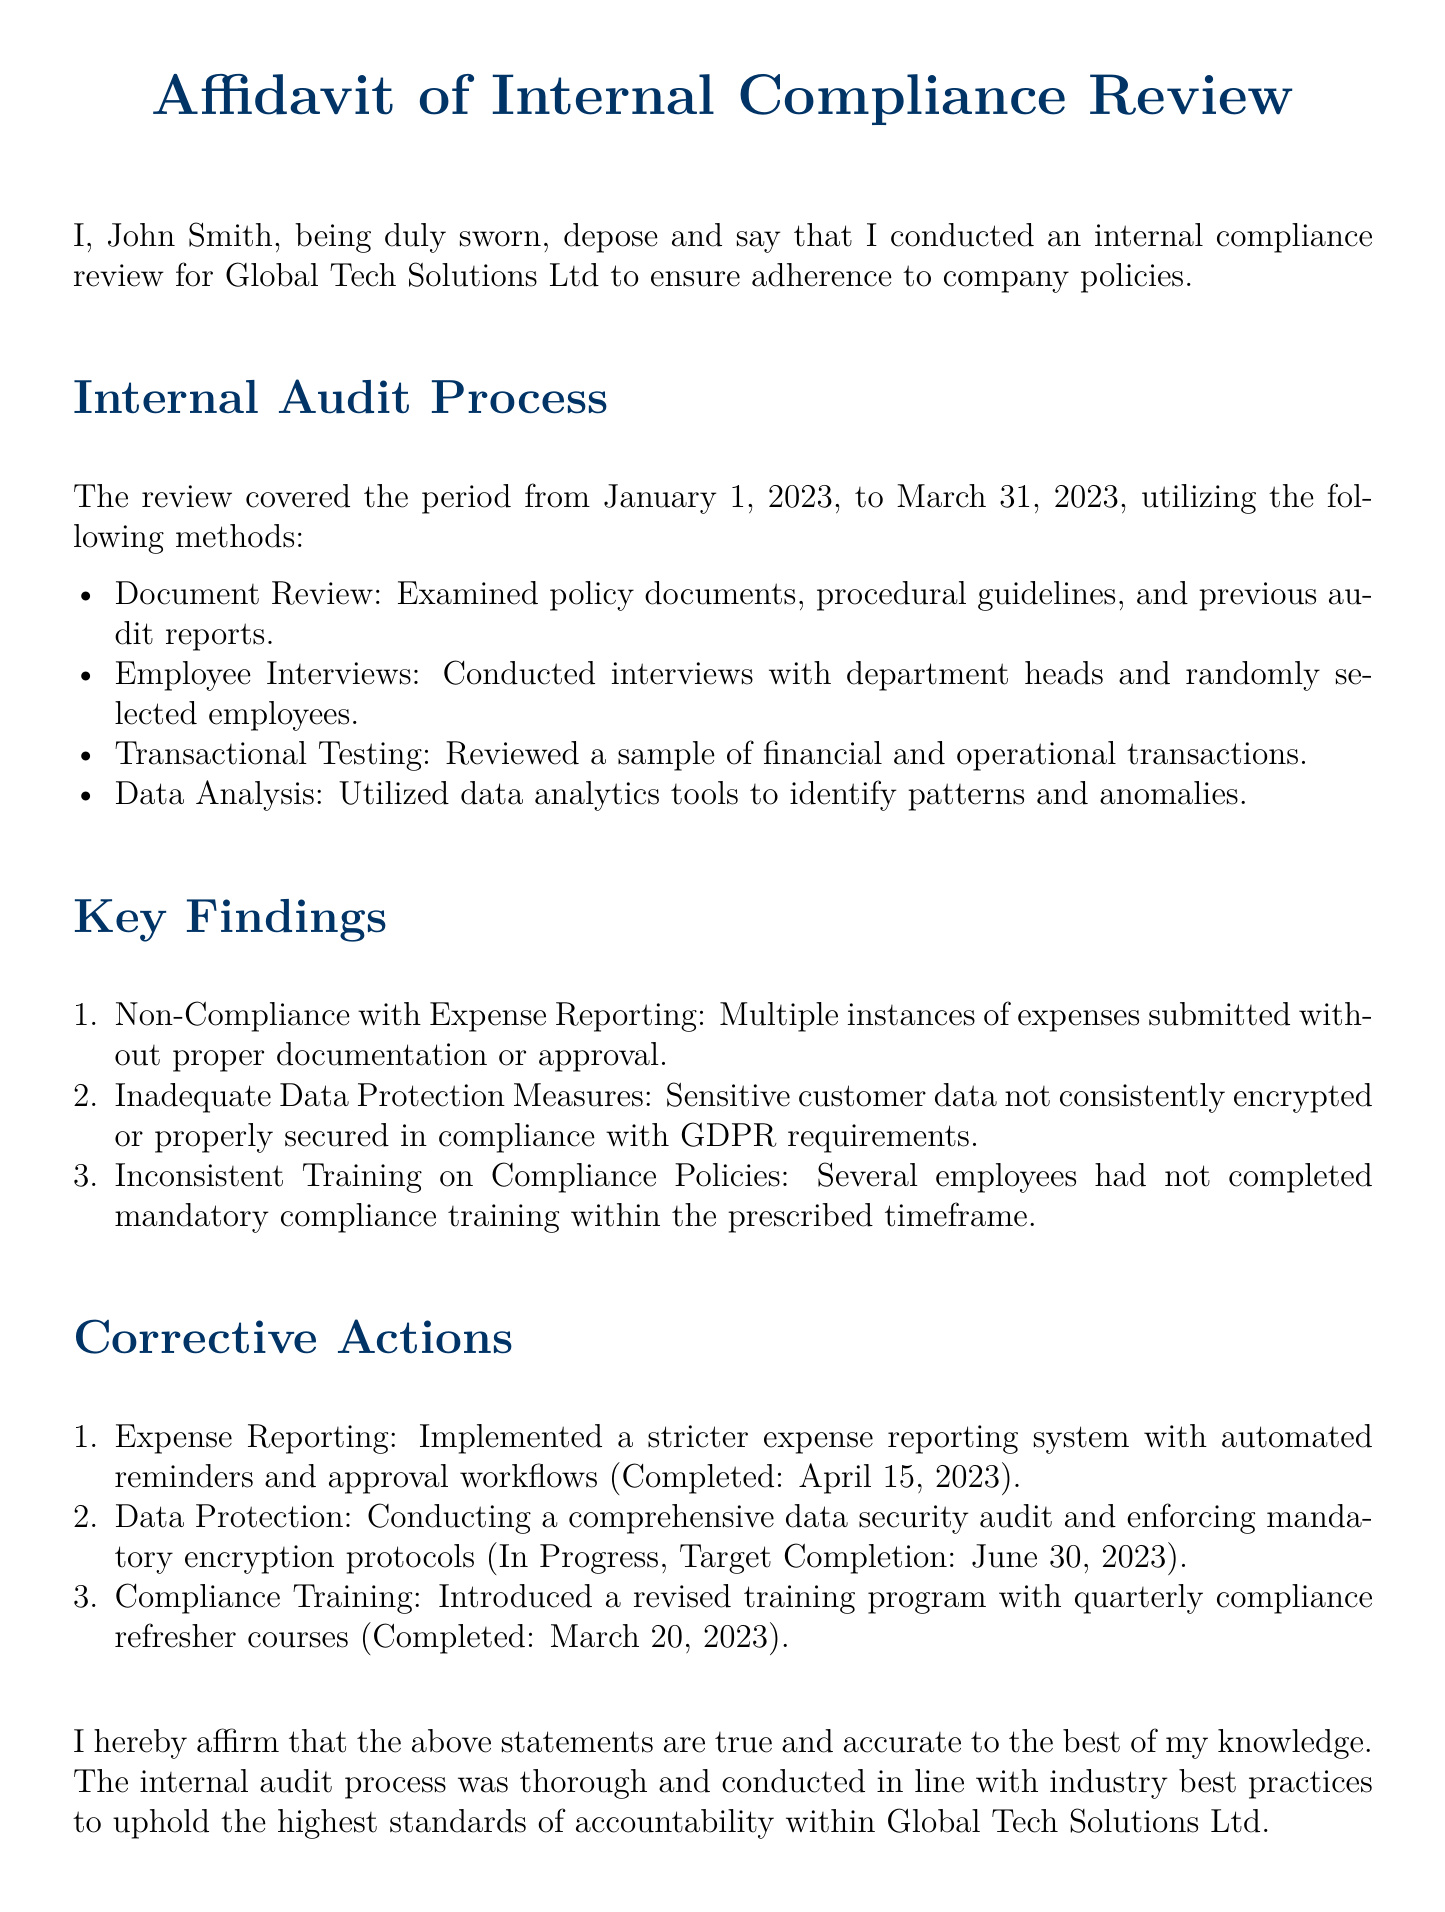What is the name of the organization reviewed? The affidavit states that the internal compliance review was conducted for Global Tech Solutions Ltd.
Answer: Global Tech Solutions Ltd Who conducted the internal audit? The document indicates that John Smith conducted the internal compliance review.
Answer: John Smith What was the date range for the internal audit process? The review covered the period from January 1, 2023, to March 31, 2023.
Answer: January 1, 2023, to March 31, 2023 How many key findings were identified in the audit? The audited report lists three key findings.
Answer: Three What corrective action was completed on April 15, 2023? The affidavit specifies that a stricter expense reporting system was implemented on that date.
Answer: Stricter expense reporting system What is the target completion date for the data protection audit? According to the document, the target completion date for the data security audit is June 30, 2023.
Answer: June 30, 2023 What type of training program was introduced? The summary indicates that a revised training program with quarterly compliance refresher courses was introduced.
Answer: Revised training program with quarterly compliance refresher courses What is the title of the individual who signed the affidavit? The document identifies the individual as the Chief Compliance Officer.
Answer: Chief Compliance Officer What was one method used in the internal audit process? The affidavit mentions multiple methods including document review, interviews, transactional testing, and data analysis; one method is document review.
Answer: Document review 